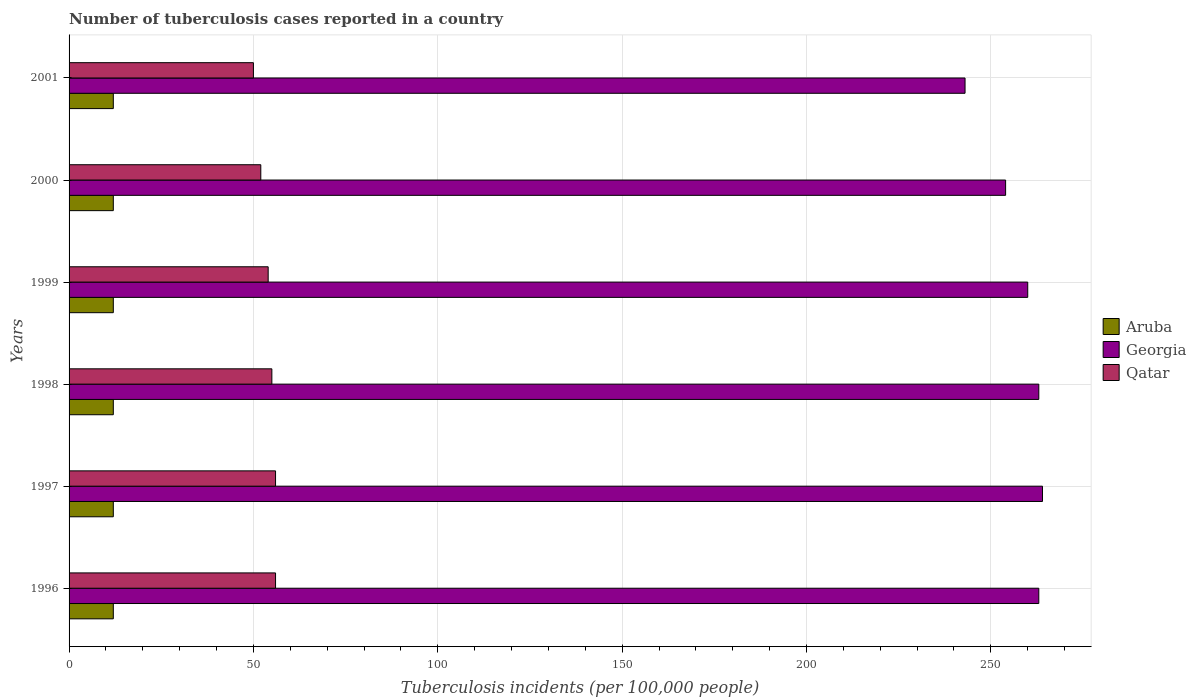How many groups of bars are there?
Your answer should be very brief. 6. Are the number of bars per tick equal to the number of legend labels?
Offer a very short reply. Yes. Are the number of bars on each tick of the Y-axis equal?
Keep it short and to the point. Yes. What is the number of tuberculosis cases reported in in Aruba in 1997?
Ensure brevity in your answer.  12. Across all years, what is the maximum number of tuberculosis cases reported in in Georgia?
Your response must be concise. 264. Across all years, what is the minimum number of tuberculosis cases reported in in Aruba?
Give a very brief answer. 12. What is the total number of tuberculosis cases reported in in Aruba in the graph?
Provide a succinct answer. 72. What is the difference between the number of tuberculosis cases reported in in Georgia in 1998 and that in 1999?
Offer a terse response. 3. What is the difference between the number of tuberculosis cases reported in in Georgia in 1998 and the number of tuberculosis cases reported in in Aruba in 2001?
Your response must be concise. 251. What is the average number of tuberculosis cases reported in in Qatar per year?
Keep it short and to the point. 53.83. In the year 1999, what is the difference between the number of tuberculosis cases reported in in Aruba and number of tuberculosis cases reported in in Georgia?
Provide a succinct answer. -248. What is the ratio of the number of tuberculosis cases reported in in Georgia in 1996 to that in 1999?
Provide a succinct answer. 1.01. Is the number of tuberculosis cases reported in in Georgia in 1998 less than that in 2000?
Ensure brevity in your answer.  No. Is the difference between the number of tuberculosis cases reported in in Aruba in 1999 and 2001 greater than the difference between the number of tuberculosis cases reported in in Georgia in 1999 and 2001?
Your answer should be compact. No. What is the difference between the highest and the lowest number of tuberculosis cases reported in in Georgia?
Provide a short and direct response. 21. In how many years, is the number of tuberculosis cases reported in in Georgia greater than the average number of tuberculosis cases reported in in Georgia taken over all years?
Provide a succinct answer. 4. Is the sum of the number of tuberculosis cases reported in in Qatar in 2000 and 2001 greater than the maximum number of tuberculosis cases reported in in Georgia across all years?
Provide a short and direct response. No. What does the 3rd bar from the top in 1997 represents?
Provide a succinct answer. Aruba. What does the 2nd bar from the bottom in 1996 represents?
Keep it short and to the point. Georgia. Are all the bars in the graph horizontal?
Your response must be concise. Yes. What is the difference between two consecutive major ticks on the X-axis?
Your answer should be very brief. 50. Are the values on the major ticks of X-axis written in scientific E-notation?
Ensure brevity in your answer.  No. Does the graph contain any zero values?
Your answer should be very brief. No. Does the graph contain grids?
Offer a very short reply. Yes. Where does the legend appear in the graph?
Your answer should be compact. Center right. How many legend labels are there?
Your answer should be very brief. 3. How are the legend labels stacked?
Make the answer very short. Vertical. What is the title of the graph?
Keep it short and to the point. Number of tuberculosis cases reported in a country. Does "Hungary" appear as one of the legend labels in the graph?
Provide a short and direct response. No. What is the label or title of the X-axis?
Make the answer very short. Tuberculosis incidents (per 100,0 people). What is the label or title of the Y-axis?
Your response must be concise. Years. What is the Tuberculosis incidents (per 100,000 people) in Georgia in 1996?
Your answer should be compact. 263. What is the Tuberculosis incidents (per 100,000 people) of Qatar in 1996?
Give a very brief answer. 56. What is the Tuberculosis incidents (per 100,000 people) of Georgia in 1997?
Your response must be concise. 264. What is the Tuberculosis incidents (per 100,000 people) of Georgia in 1998?
Make the answer very short. 263. What is the Tuberculosis incidents (per 100,000 people) in Georgia in 1999?
Your answer should be compact. 260. What is the Tuberculosis incidents (per 100,000 people) of Qatar in 1999?
Provide a succinct answer. 54. What is the Tuberculosis incidents (per 100,000 people) in Georgia in 2000?
Your answer should be compact. 254. What is the Tuberculosis incidents (per 100,000 people) of Qatar in 2000?
Make the answer very short. 52. What is the Tuberculosis incidents (per 100,000 people) in Georgia in 2001?
Give a very brief answer. 243. Across all years, what is the maximum Tuberculosis incidents (per 100,000 people) in Aruba?
Offer a very short reply. 12. Across all years, what is the maximum Tuberculosis incidents (per 100,000 people) of Georgia?
Offer a terse response. 264. Across all years, what is the minimum Tuberculosis incidents (per 100,000 people) of Aruba?
Give a very brief answer. 12. Across all years, what is the minimum Tuberculosis incidents (per 100,000 people) of Georgia?
Provide a short and direct response. 243. What is the total Tuberculosis incidents (per 100,000 people) of Aruba in the graph?
Offer a very short reply. 72. What is the total Tuberculosis incidents (per 100,000 people) in Georgia in the graph?
Your response must be concise. 1547. What is the total Tuberculosis incidents (per 100,000 people) of Qatar in the graph?
Offer a very short reply. 323. What is the difference between the Tuberculosis incidents (per 100,000 people) in Georgia in 1996 and that in 1997?
Provide a short and direct response. -1. What is the difference between the Tuberculosis incidents (per 100,000 people) in Aruba in 1996 and that in 1998?
Make the answer very short. 0. What is the difference between the Tuberculosis incidents (per 100,000 people) in Qatar in 1996 and that in 1998?
Your response must be concise. 1. What is the difference between the Tuberculosis incidents (per 100,000 people) in Georgia in 1996 and that in 1999?
Give a very brief answer. 3. What is the difference between the Tuberculosis incidents (per 100,000 people) in Aruba in 1996 and that in 2000?
Keep it short and to the point. 0. What is the difference between the Tuberculosis incidents (per 100,000 people) of Georgia in 1996 and that in 2001?
Your response must be concise. 20. What is the difference between the Tuberculosis incidents (per 100,000 people) in Georgia in 1997 and that in 1999?
Make the answer very short. 4. What is the difference between the Tuberculosis incidents (per 100,000 people) of Qatar in 1997 and that in 2000?
Your answer should be compact. 4. What is the difference between the Tuberculosis incidents (per 100,000 people) of Georgia in 1997 and that in 2001?
Ensure brevity in your answer.  21. What is the difference between the Tuberculosis incidents (per 100,000 people) in Qatar in 1997 and that in 2001?
Make the answer very short. 6. What is the difference between the Tuberculosis incidents (per 100,000 people) in Qatar in 1998 and that in 1999?
Your response must be concise. 1. What is the difference between the Tuberculosis incidents (per 100,000 people) in Georgia in 1998 and that in 2000?
Give a very brief answer. 9. What is the difference between the Tuberculosis incidents (per 100,000 people) of Qatar in 1998 and that in 2000?
Keep it short and to the point. 3. What is the difference between the Tuberculosis incidents (per 100,000 people) in Aruba in 1998 and that in 2001?
Ensure brevity in your answer.  0. What is the difference between the Tuberculosis incidents (per 100,000 people) of Qatar in 1998 and that in 2001?
Make the answer very short. 5. What is the difference between the Tuberculosis incidents (per 100,000 people) of Aruba in 1999 and that in 2001?
Offer a very short reply. 0. What is the difference between the Tuberculosis incidents (per 100,000 people) in Georgia in 1999 and that in 2001?
Offer a terse response. 17. What is the difference between the Tuberculosis incidents (per 100,000 people) of Qatar in 1999 and that in 2001?
Make the answer very short. 4. What is the difference between the Tuberculosis incidents (per 100,000 people) in Georgia in 2000 and that in 2001?
Provide a succinct answer. 11. What is the difference between the Tuberculosis incidents (per 100,000 people) of Qatar in 2000 and that in 2001?
Ensure brevity in your answer.  2. What is the difference between the Tuberculosis incidents (per 100,000 people) of Aruba in 1996 and the Tuberculosis incidents (per 100,000 people) of Georgia in 1997?
Your answer should be very brief. -252. What is the difference between the Tuberculosis incidents (per 100,000 people) of Aruba in 1996 and the Tuberculosis incidents (per 100,000 people) of Qatar in 1997?
Provide a short and direct response. -44. What is the difference between the Tuberculosis incidents (per 100,000 people) of Georgia in 1996 and the Tuberculosis incidents (per 100,000 people) of Qatar in 1997?
Make the answer very short. 207. What is the difference between the Tuberculosis incidents (per 100,000 people) of Aruba in 1996 and the Tuberculosis incidents (per 100,000 people) of Georgia in 1998?
Provide a short and direct response. -251. What is the difference between the Tuberculosis incidents (per 100,000 people) of Aruba in 1996 and the Tuberculosis incidents (per 100,000 people) of Qatar in 1998?
Your answer should be compact. -43. What is the difference between the Tuberculosis incidents (per 100,000 people) in Georgia in 1996 and the Tuberculosis incidents (per 100,000 people) in Qatar in 1998?
Provide a succinct answer. 208. What is the difference between the Tuberculosis incidents (per 100,000 people) of Aruba in 1996 and the Tuberculosis incidents (per 100,000 people) of Georgia in 1999?
Ensure brevity in your answer.  -248. What is the difference between the Tuberculosis incidents (per 100,000 people) in Aruba in 1996 and the Tuberculosis incidents (per 100,000 people) in Qatar in 1999?
Offer a terse response. -42. What is the difference between the Tuberculosis incidents (per 100,000 people) of Georgia in 1996 and the Tuberculosis incidents (per 100,000 people) of Qatar in 1999?
Your answer should be very brief. 209. What is the difference between the Tuberculosis incidents (per 100,000 people) in Aruba in 1996 and the Tuberculosis incidents (per 100,000 people) in Georgia in 2000?
Make the answer very short. -242. What is the difference between the Tuberculosis incidents (per 100,000 people) of Aruba in 1996 and the Tuberculosis incidents (per 100,000 people) of Qatar in 2000?
Make the answer very short. -40. What is the difference between the Tuberculosis incidents (per 100,000 people) of Georgia in 1996 and the Tuberculosis incidents (per 100,000 people) of Qatar in 2000?
Your answer should be compact. 211. What is the difference between the Tuberculosis incidents (per 100,000 people) of Aruba in 1996 and the Tuberculosis incidents (per 100,000 people) of Georgia in 2001?
Your response must be concise. -231. What is the difference between the Tuberculosis incidents (per 100,000 people) of Aruba in 1996 and the Tuberculosis incidents (per 100,000 people) of Qatar in 2001?
Your response must be concise. -38. What is the difference between the Tuberculosis incidents (per 100,000 people) in Georgia in 1996 and the Tuberculosis incidents (per 100,000 people) in Qatar in 2001?
Your response must be concise. 213. What is the difference between the Tuberculosis incidents (per 100,000 people) in Aruba in 1997 and the Tuberculosis incidents (per 100,000 people) in Georgia in 1998?
Offer a terse response. -251. What is the difference between the Tuberculosis incidents (per 100,000 people) in Aruba in 1997 and the Tuberculosis incidents (per 100,000 people) in Qatar in 1998?
Offer a very short reply. -43. What is the difference between the Tuberculosis incidents (per 100,000 people) in Georgia in 1997 and the Tuberculosis incidents (per 100,000 people) in Qatar in 1998?
Make the answer very short. 209. What is the difference between the Tuberculosis incidents (per 100,000 people) of Aruba in 1997 and the Tuberculosis incidents (per 100,000 people) of Georgia in 1999?
Your answer should be very brief. -248. What is the difference between the Tuberculosis incidents (per 100,000 people) of Aruba in 1997 and the Tuberculosis incidents (per 100,000 people) of Qatar in 1999?
Your answer should be very brief. -42. What is the difference between the Tuberculosis incidents (per 100,000 people) of Georgia in 1997 and the Tuberculosis incidents (per 100,000 people) of Qatar in 1999?
Provide a short and direct response. 210. What is the difference between the Tuberculosis incidents (per 100,000 people) in Aruba in 1997 and the Tuberculosis incidents (per 100,000 people) in Georgia in 2000?
Give a very brief answer. -242. What is the difference between the Tuberculosis incidents (per 100,000 people) in Aruba in 1997 and the Tuberculosis incidents (per 100,000 people) in Qatar in 2000?
Your response must be concise. -40. What is the difference between the Tuberculosis incidents (per 100,000 people) of Georgia in 1997 and the Tuberculosis incidents (per 100,000 people) of Qatar in 2000?
Your answer should be compact. 212. What is the difference between the Tuberculosis incidents (per 100,000 people) in Aruba in 1997 and the Tuberculosis incidents (per 100,000 people) in Georgia in 2001?
Your answer should be very brief. -231. What is the difference between the Tuberculosis incidents (per 100,000 people) of Aruba in 1997 and the Tuberculosis incidents (per 100,000 people) of Qatar in 2001?
Ensure brevity in your answer.  -38. What is the difference between the Tuberculosis incidents (per 100,000 people) in Georgia in 1997 and the Tuberculosis incidents (per 100,000 people) in Qatar in 2001?
Make the answer very short. 214. What is the difference between the Tuberculosis incidents (per 100,000 people) of Aruba in 1998 and the Tuberculosis incidents (per 100,000 people) of Georgia in 1999?
Keep it short and to the point. -248. What is the difference between the Tuberculosis incidents (per 100,000 people) in Aruba in 1998 and the Tuberculosis incidents (per 100,000 people) in Qatar in 1999?
Offer a very short reply. -42. What is the difference between the Tuberculosis incidents (per 100,000 people) in Georgia in 1998 and the Tuberculosis incidents (per 100,000 people) in Qatar in 1999?
Offer a very short reply. 209. What is the difference between the Tuberculosis incidents (per 100,000 people) of Aruba in 1998 and the Tuberculosis incidents (per 100,000 people) of Georgia in 2000?
Provide a succinct answer. -242. What is the difference between the Tuberculosis incidents (per 100,000 people) of Georgia in 1998 and the Tuberculosis incidents (per 100,000 people) of Qatar in 2000?
Ensure brevity in your answer.  211. What is the difference between the Tuberculosis incidents (per 100,000 people) of Aruba in 1998 and the Tuberculosis incidents (per 100,000 people) of Georgia in 2001?
Make the answer very short. -231. What is the difference between the Tuberculosis incidents (per 100,000 people) in Aruba in 1998 and the Tuberculosis incidents (per 100,000 people) in Qatar in 2001?
Give a very brief answer. -38. What is the difference between the Tuberculosis incidents (per 100,000 people) in Georgia in 1998 and the Tuberculosis incidents (per 100,000 people) in Qatar in 2001?
Provide a short and direct response. 213. What is the difference between the Tuberculosis incidents (per 100,000 people) of Aruba in 1999 and the Tuberculosis incidents (per 100,000 people) of Georgia in 2000?
Provide a succinct answer. -242. What is the difference between the Tuberculosis incidents (per 100,000 people) in Georgia in 1999 and the Tuberculosis incidents (per 100,000 people) in Qatar in 2000?
Provide a short and direct response. 208. What is the difference between the Tuberculosis incidents (per 100,000 people) of Aruba in 1999 and the Tuberculosis incidents (per 100,000 people) of Georgia in 2001?
Your response must be concise. -231. What is the difference between the Tuberculosis incidents (per 100,000 people) in Aruba in 1999 and the Tuberculosis incidents (per 100,000 people) in Qatar in 2001?
Provide a succinct answer. -38. What is the difference between the Tuberculosis incidents (per 100,000 people) in Georgia in 1999 and the Tuberculosis incidents (per 100,000 people) in Qatar in 2001?
Provide a succinct answer. 210. What is the difference between the Tuberculosis incidents (per 100,000 people) in Aruba in 2000 and the Tuberculosis incidents (per 100,000 people) in Georgia in 2001?
Make the answer very short. -231. What is the difference between the Tuberculosis incidents (per 100,000 people) of Aruba in 2000 and the Tuberculosis incidents (per 100,000 people) of Qatar in 2001?
Offer a terse response. -38. What is the difference between the Tuberculosis incidents (per 100,000 people) in Georgia in 2000 and the Tuberculosis incidents (per 100,000 people) in Qatar in 2001?
Provide a short and direct response. 204. What is the average Tuberculosis incidents (per 100,000 people) of Georgia per year?
Keep it short and to the point. 257.83. What is the average Tuberculosis incidents (per 100,000 people) in Qatar per year?
Make the answer very short. 53.83. In the year 1996, what is the difference between the Tuberculosis incidents (per 100,000 people) of Aruba and Tuberculosis incidents (per 100,000 people) of Georgia?
Keep it short and to the point. -251. In the year 1996, what is the difference between the Tuberculosis incidents (per 100,000 people) of Aruba and Tuberculosis incidents (per 100,000 people) of Qatar?
Your answer should be compact. -44. In the year 1996, what is the difference between the Tuberculosis incidents (per 100,000 people) of Georgia and Tuberculosis incidents (per 100,000 people) of Qatar?
Your response must be concise. 207. In the year 1997, what is the difference between the Tuberculosis incidents (per 100,000 people) in Aruba and Tuberculosis incidents (per 100,000 people) in Georgia?
Your answer should be very brief. -252. In the year 1997, what is the difference between the Tuberculosis incidents (per 100,000 people) of Aruba and Tuberculosis incidents (per 100,000 people) of Qatar?
Provide a succinct answer. -44. In the year 1997, what is the difference between the Tuberculosis incidents (per 100,000 people) in Georgia and Tuberculosis incidents (per 100,000 people) in Qatar?
Your answer should be compact. 208. In the year 1998, what is the difference between the Tuberculosis incidents (per 100,000 people) in Aruba and Tuberculosis incidents (per 100,000 people) in Georgia?
Your answer should be very brief. -251. In the year 1998, what is the difference between the Tuberculosis incidents (per 100,000 people) of Aruba and Tuberculosis incidents (per 100,000 people) of Qatar?
Ensure brevity in your answer.  -43. In the year 1998, what is the difference between the Tuberculosis incidents (per 100,000 people) of Georgia and Tuberculosis incidents (per 100,000 people) of Qatar?
Offer a very short reply. 208. In the year 1999, what is the difference between the Tuberculosis incidents (per 100,000 people) of Aruba and Tuberculosis incidents (per 100,000 people) of Georgia?
Your response must be concise. -248. In the year 1999, what is the difference between the Tuberculosis incidents (per 100,000 people) of Aruba and Tuberculosis incidents (per 100,000 people) of Qatar?
Ensure brevity in your answer.  -42. In the year 1999, what is the difference between the Tuberculosis incidents (per 100,000 people) in Georgia and Tuberculosis incidents (per 100,000 people) in Qatar?
Your response must be concise. 206. In the year 2000, what is the difference between the Tuberculosis incidents (per 100,000 people) in Aruba and Tuberculosis incidents (per 100,000 people) in Georgia?
Your answer should be very brief. -242. In the year 2000, what is the difference between the Tuberculosis incidents (per 100,000 people) in Aruba and Tuberculosis incidents (per 100,000 people) in Qatar?
Give a very brief answer. -40. In the year 2000, what is the difference between the Tuberculosis incidents (per 100,000 people) in Georgia and Tuberculosis incidents (per 100,000 people) in Qatar?
Keep it short and to the point. 202. In the year 2001, what is the difference between the Tuberculosis incidents (per 100,000 people) in Aruba and Tuberculosis incidents (per 100,000 people) in Georgia?
Make the answer very short. -231. In the year 2001, what is the difference between the Tuberculosis incidents (per 100,000 people) in Aruba and Tuberculosis incidents (per 100,000 people) in Qatar?
Make the answer very short. -38. In the year 2001, what is the difference between the Tuberculosis incidents (per 100,000 people) in Georgia and Tuberculosis incidents (per 100,000 people) in Qatar?
Your answer should be very brief. 193. What is the ratio of the Tuberculosis incidents (per 100,000 people) in Qatar in 1996 to that in 1997?
Provide a short and direct response. 1. What is the ratio of the Tuberculosis incidents (per 100,000 people) of Aruba in 1996 to that in 1998?
Offer a terse response. 1. What is the ratio of the Tuberculosis incidents (per 100,000 people) of Qatar in 1996 to that in 1998?
Provide a short and direct response. 1.02. What is the ratio of the Tuberculosis incidents (per 100,000 people) in Georgia in 1996 to that in 1999?
Provide a short and direct response. 1.01. What is the ratio of the Tuberculosis incidents (per 100,000 people) of Qatar in 1996 to that in 1999?
Make the answer very short. 1.04. What is the ratio of the Tuberculosis incidents (per 100,000 people) of Aruba in 1996 to that in 2000?
Offer a very short reply. 1. What is the ratio of the Tuberculosis incidents (per 100,000 people) of Georgia in 1996 to that in 2000?
Provide a short and direct response. 1.04. What is the ratio of the Tuberculosis incidents (per 100,000 people) in Qatar in 1996 to that in 2000?
Offer a very short reply. 1.08. What is the ratio of the Tuberculosis incidents (per 100,000 people) of Georgia in 1996 to that in 2001?
Offer a terse response. 1.08. What is the ratio of the Tuberculosis incidents (per 100,000 people) of Qatar in 1996 to that in 2001?
Offer a very short reply. 1.12. What is the ratio of the Tuberculosis incidents (per 100,000 people) of Aruba in 1997 to that in 1998?
Offer a very short reply. 1. What is the ratio of the Tuberculosis incidents (per 100,000 people) in Qatar in 1997 to that in 1998?
Keep it short and to the point. 1.02. What is the ratio of the Tuberculosis incidents (per 100,000 people) of Georgia in 1997 to that in 1999?
Your answer should be very brief. 1.02. What is the ratio of the Tuberculosis incidents (per 100,000 people) in Georgia in 1997 to that in 2000?
Offer a terse response. 1.04. What is the ratio of the Tuberculosis incidents (per 100,000 people) in Georgia in 1997 to that in 2001?
Provide a short and direct response. 1.09. What is the ratio of the Tuberculosis incidents (per 100,000 people) of Qatar in 1997 to that in 2001?
Make the answer very short. 1.12. What is the ratio of the Tuberculosis incidents (per 100,000 people) in Aruba in 1998 to that in 1999?
Offer a terse response. 1. What is the ratio of the Tuberculosis incidents (per 100,000 people) of Georgia in 1998 to that in 1999?
Your answer should be very brief. 1.01. What is the ratio of the Tuberculosis incidents (per 100,000 people) in Qatar in 1998 to that in 1999?
Keep it short and to the point. 1.02. What is the ratio of the Tuberculosis incidents (per 100,000 people) of Georgia in 1998 to that in 2000?
Offer a terse response. 1.04. What is the ratio of the Tuberculosis incidents (per 100,000 people) of Qatar in 1998 to that in 2000?
Ensure brevity in your answer.  1.06. What is the ratio of the Tuberculosis incidents (per 100,000 people) in Aruba in 1998 to that in 2001?
Offer a terse response. 1. What is the ratio of the Tuberculosis incidents (per 100,000 people) in Georgia in 1998 to that in 2001?
Offer a terse response. 1.08. What is the ratio of the Tuberculosis incidents (per 100,000 people) of Aruba in 1999 to that in 2000?
Keep it short and to the point. 1. What is the ratio of the Tuberculosis incidents (per 100,000 people) of Georgia in 1999 to that in 2000?
Offer a terse response. 1.02. What is the ratio of the Tuberculosis incidents (per 100,000 people) in Qatar in 1999 to that in 2000?
Make the answer very short. 1.04. What is the ratio of the Tuberculosis incidents (per 100,000 people) in Georgia in 1999 to that in 2001?
Make the answer very short. 1.07. What is the ratio of the Tuberculosis incidents (per 100,000 people) in Georgia in 2000 to that in 2001?
Offer a terse response. 1.05. What is the ratio of the Tuberculosis incidents (per 100,000 people) in Qatar in 2000 to that in 2001?
Ensure brevity in your answer.  1.04. What is the difference between the highest and the second highest Tuberculosis incidents (per 100,000 people) of Aruba?
Provide a short and direct response. 0. What is the difference between the highest and the second highest Tuberculosis incidents (per 100,000 people) in Georgia?
Offer a very short reply. 1. What is the difference between the highest and the lowest Tuberculosis incidents (per 100,000 people) of Aruba?
Your answer should be compact. 0. 